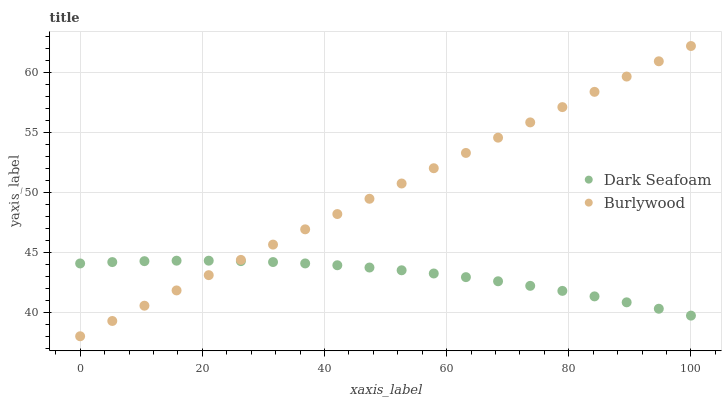Does Dark Seafoam have the minimum area under the curve?
Answer yes or no. Yes. Does Burlywood have the maximum area under the curve?
Answer yes or no. Yes. Does Dark Seafoam have the maximum area under the curve?
Answer yes or no. No. Is Burlywood the smoothest?
Answer yes or no. Yes. Is Dark Seafoam the roughest?
Answer yes or no. Yes. Is Dark Seafoam the smoothest?
Answer yes or no. No. Does Burlywood have the lowest value?
Answer yes or no. Yes. Does Dark Seafoam have the lowest value?
Answer yes or no. No. Does Burlywood have the highest value?
Answer yes or no. Yes. Does Dark Seafoam have the highest value?
Answer yes or no. No. Does Dark Seafoam intersect Burlywood?
Answer yes or no. Yes. Is Dark Seafoam less than Burlywood?
Answer yes or no. No. Is Dark Seafoam greater than Burlywood?
Answer yes or no. No. 